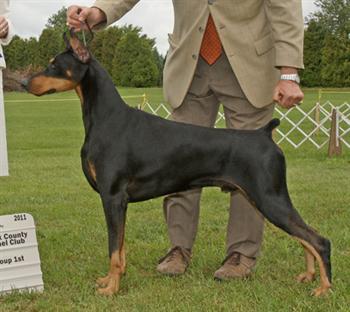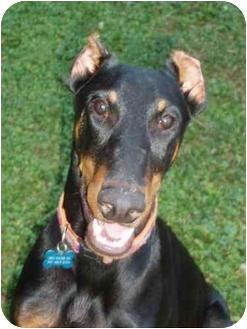The first image is the image on the left, the second image is the image on the right. Examine the images to the left and right. Is the description "One image shows a camera-gazing doberman with a blue tag dangling from its collar and stubby-looking ears." accurate? Answer yes or no. Yes. The first image is the image on the left, the second image is the image on the right. Given the left and right images, does the statement "There are two dogs." hold true? Answer yes or no. Yes. 